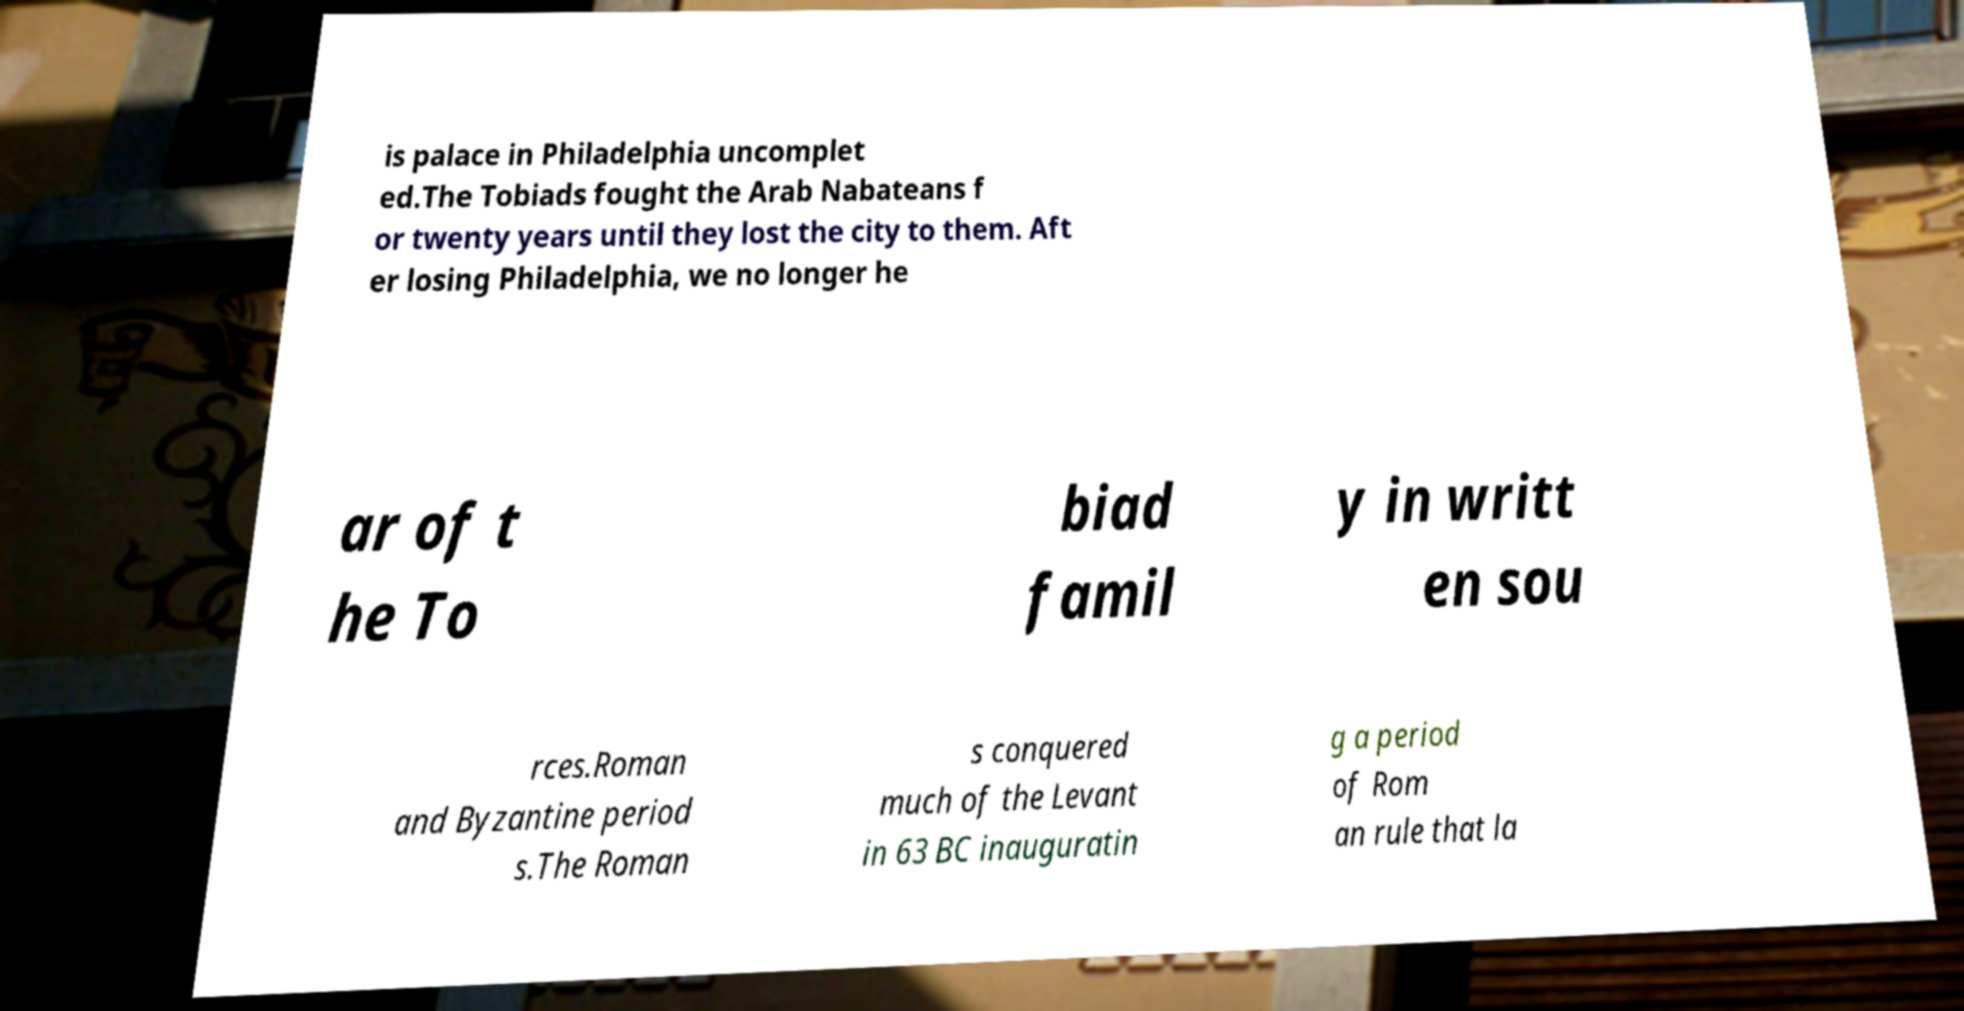Can you read and provide the text displayed in the image?This photo seems to have some interesting text. Can you extract and type it out for me? is palace in Philadelphia uncomplet ed.The Tobiads fought the Arab Nabateans f or twenty years until they lost the city to them. Aft er losing Philadelphia, we no longer he ar of t he To biad famil y in writt en sou rces.Roman and Byzantine period s.The Roman s conquered much of the Levant in 63 BC inauguratin g a period of Rom an rule that la 